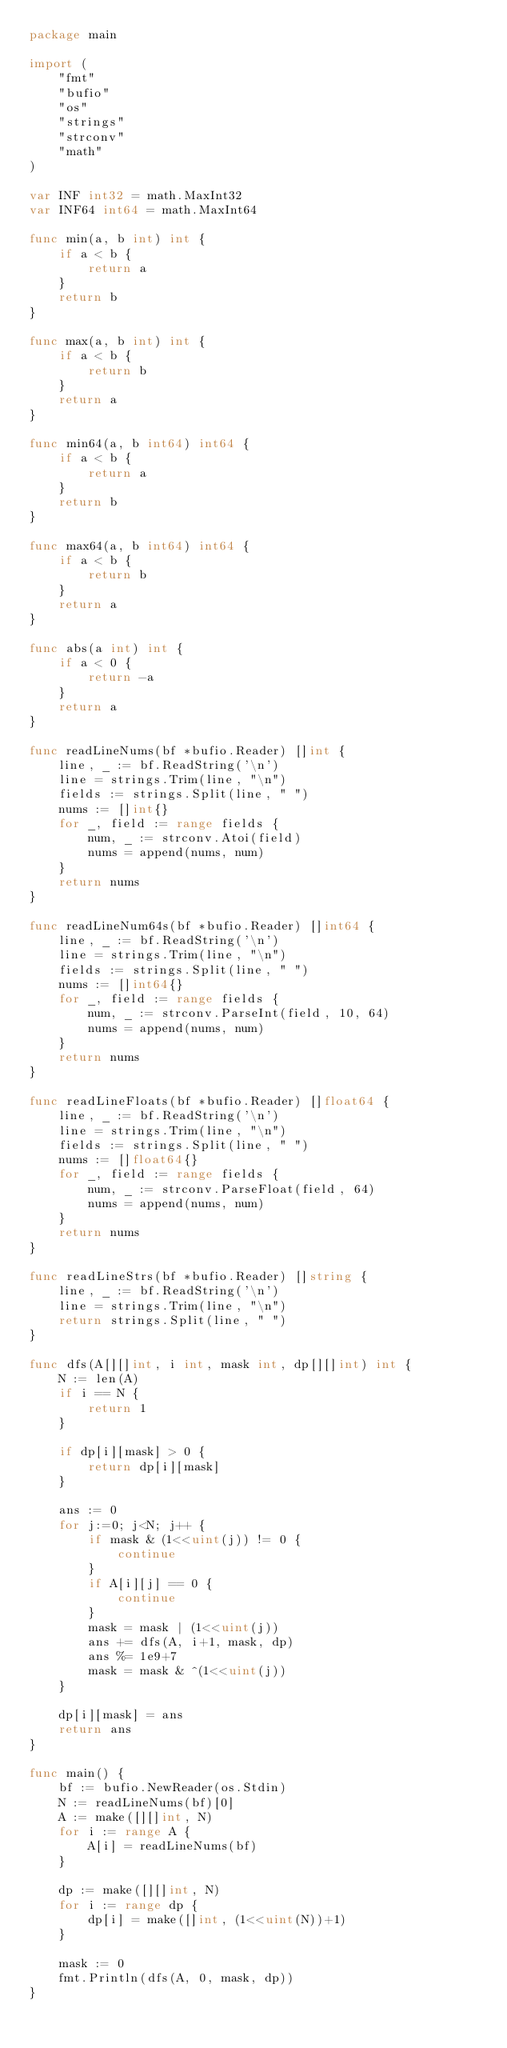Convert code to text. <code><loc_0><loc_0><loc_500><loc_500><_Go_>package main

import (
	"fmt"
	"bufio"
	"os"
	"strings"
	"strconv"
	"math"
)

var INF int32 = math.MaxInt32
var INF64 int64 = math.MaxInt64

func min(a, b int) int {
	if a < b {
		return a
	}
	return b
}

func max(a, b int) int {
	if a < b {
		return b
	}
	return a
}

func min64(a, b int64) int64 {
	if a < b {
		return a
	}
	return b
}

func max64(a, b int64) int64 {
	if a < b {
		return b
	}
	return a
}

func abs(a int) int {
	if a < 0 {
		return -a
	}
	return a
}

func readLineNums(bf *bufio.Reader) []int {
	line, _ := bf.ReadString('\n')
	line = strings.Trim(line, "\n")
	fields := strings.Split(line, " ")
	nums := []int{}
	for _, field := range fields {
		num, _ := strconv.Atoi(field)
		nums = append(nums, num)
	}
	return nums
}

func readLineNum64s(bf *bufio.Reader) []int64 {
	line, _ := bf.ReadString('\n')
	line = strings.Trim(line, "\n")
	fields := strings.Split(line, " ")
	nums := []int64{}
	for _, field := range fields {
		num, _ := strconv.ParseInt(field, 10, 64)
		nums = append(nums, num)
	}
	return nums
}

func readLineFloats(bf *bufio.Reader) []float64 {
	line, _ := bf.ReadString('\n')
	line = strings.Trim(line, "\n")
	fields := strings.Split(line, " ")
	nums := []float64{}
	for _, field := range fields {
		num, _ := strconv.ParseFloat(field, 64)
		nums = append(nums, num)
	}
	return nums
}

func readLineStrs(bf *bufio.Reader) []string {
	line, _ := bf.ReadString('\n')
	line = strings.Trim(line, "\n")
	return strings.Split(line, " ")
}

func dfs(A[][]int, i int, mask int, dp[][]int) int {
	N := len(A)
	if i == N {
		return 1
	}

	if dp[i][mask] > 0 {
		return dp[i][mask]
	}

	ans := 0
	for j:=0; j<N; j++ {
		if mask & (1<<uint(j)) != 0 {
			continue
		}
		if A[i][j] == 0 {
			continue
		}
		mask = mask | (1<<uint(j))
		ans += dfs(A, i+1, mask, dp)
		ans %= 1e9+7
		mask = mask & ^(1<<uint(j))
	}

	dp[i][mask] = ans
	return ans
}

func main() {
	bf := bufio.NewReader(os.Stdin)
	N := readLineNums(bf)[0]
	A := make([][]int, N)
	for i := range A {
		A[i] = readLineNums(bf)
	}

	dp := make([][]int, N)
	for i := range dp {
		dp[i] = make([]int, (1<<uint(N))+1)
	}

	mask := 0
	fmt.Println(dfs(A, 0, mask, dp))
}
</code> 